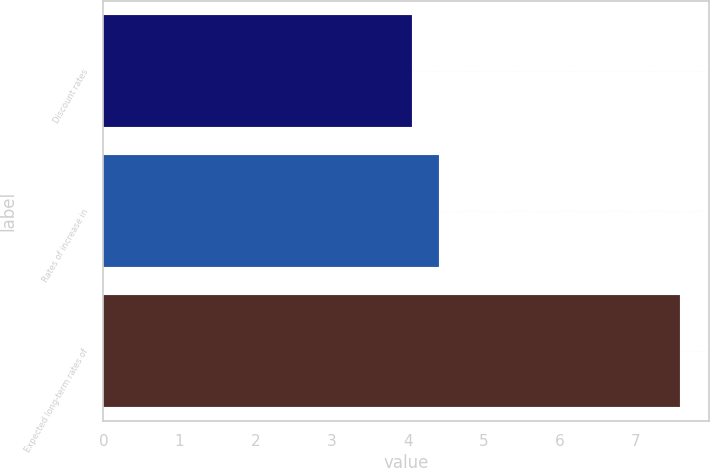<chart> <loc_0><loc_0><loc_500><loc_500><bar_chart><fcel>Discount rates<fcel>Rates of increase in<fcel>Expected long-term rates of<nl><fcel>4.06<fcel>4.41<fcel>7.58<nl></chart> 